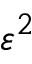<formula> <loc_0><loc_0><loc_500><loc_500>\varepsilon ^ { 2 }</formula> 